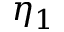Convert formula to latex. <formula><loc_0><loc_0><loc_500><loc_500>\eta _ { 1 }</formula> 